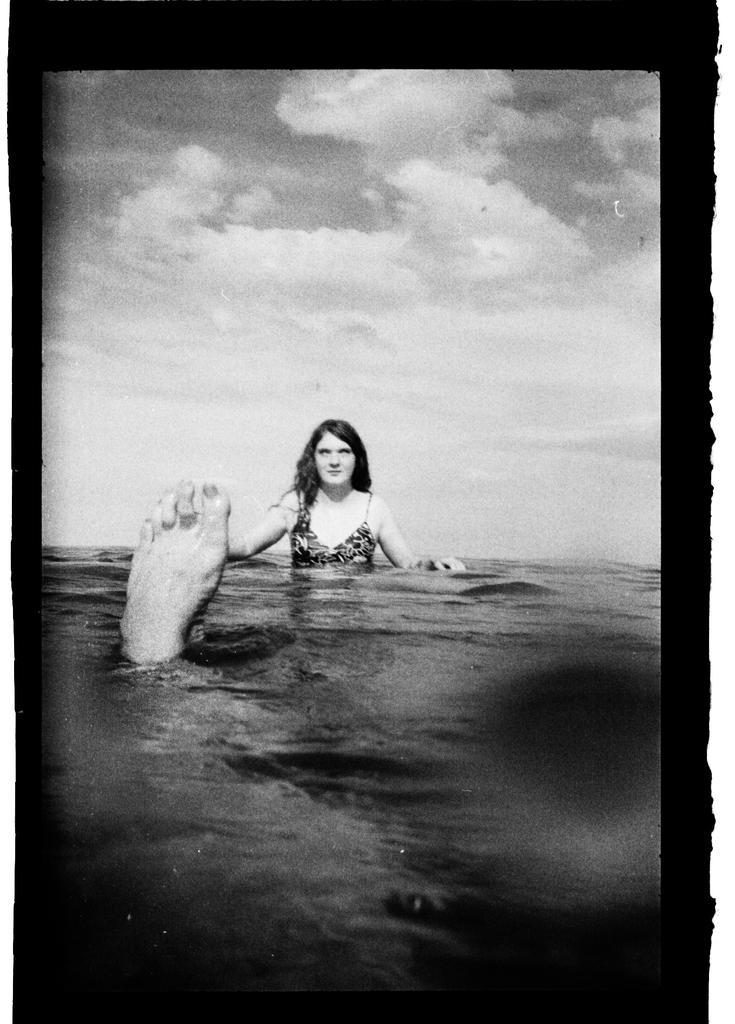In one or two sentences, can you explain what this image depicts? This is a black and white picture, in this image we can see a woman and a person's leg in the water, in the background, we can see the sky with clouds. 